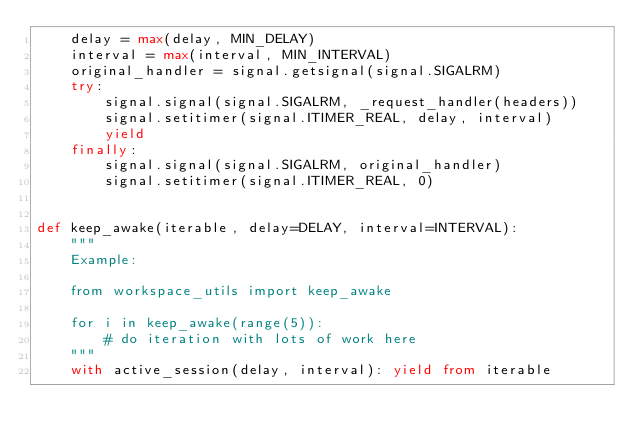Convert code to text. <code><loc_0><loc_0><loc_500><loc_500><_Python_>    delay = max(delay, MIN_DELAY)
    interval = max(interval, MIN_INTERVAL)
    original_handler = signal.getsignal(signal.SIGALRM)
    try:
        signal.signal(signal.SIGALRM, _request_handler(headers))
        signal.setitimer(signal.ITIMER_REAL, delay, interval)
        yield
    finally:
        signal.signal(signal.SIGALRM, original_handler)
        signal.setitimer(signal.ITIMER_REAL, 0)
 
 
def keep_awake(iterable, delay=DELAY, interval=INTERVAL):
    """
    Example:
 
    from workspace_utils import keep_awake
 
    for i in keep_awake(range(5)):
        # do iteration with lots of work here
    """
    with active_session(delay, interval): yield from iterable
</code> 